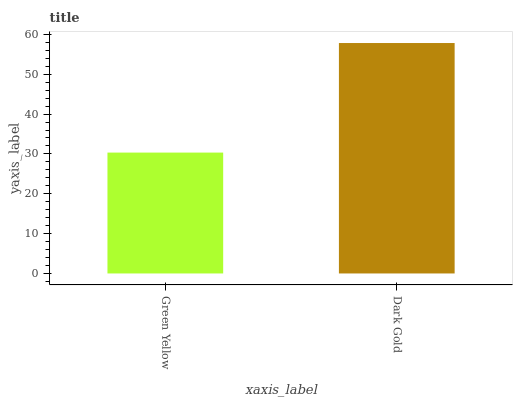Is Green Yellow the minimum?
Answer yes or no. Yes. Is Dark Gold the maximum?
Answer yes or no. Yes. Is Dark Gold the minimum?
Answer yes or no. No. Is Dark Gold greater than Green Yellow?
Answer yes or no. Yes. Is Green Yellow less than Dark Gold?
Answer yes or no. Yes. Is Green Yellow greater than Dark Gold?
Answer yes or no. No. Is Dark Gold less than Green Yellow?
Answer yes or no. No. Is Dark Gold the high median?
Answer yes or no. Yes. Is Green Yellow the low median?
Answer yes or no. Yes. Is Green Yellow the high median?
Answer yes or no. No. Is Dark Gold the low median?
Answer yes or no. No. 